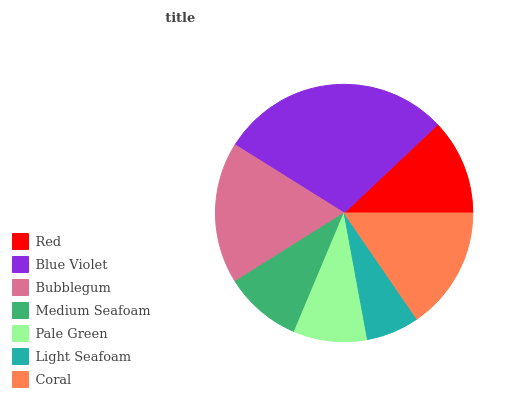Is Light Seafoam the minimum?
Answer yes or no. Yes. Is Blue Violet the maximum?
Answer yes or no. Yes. Is Bubblegum the minimum?
Answer yes or no. No. Is Bubblegum the maximum?
Answer yes or no. No. Is Blue Violet greater than Bubblegum?
Answer yes or no. Yes. Is Bubblegum less than Blue Violet?
Answer yes or no. Yes. Is Bubblegum greater than Blue Violet?
Answer yes or no. No. Is Blue Violet less than Bubblegum?
Answer yes or no. No. Is Red the high median?
Answer yes or no. Yes. Is Red the low median?
Answer yes or no. Yes. Is Light Seafoam the high median?
Answer yes or no. No. Is Pale Green the low median?
Answer yes or no. No. 